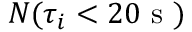Convert formula to latex. <formula><loc_0><loc_0><loc_500><loc_500>N ( \tau _ { i } < 2 0 s )</formula> 